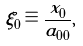Convert formula to latex. <formula><loc_0><loc_0><loc_500><loc_500>\xi _ { 0 } \equiv \frac { x _ { 0 } } { a _ { 0 0 } } ,</formula> 